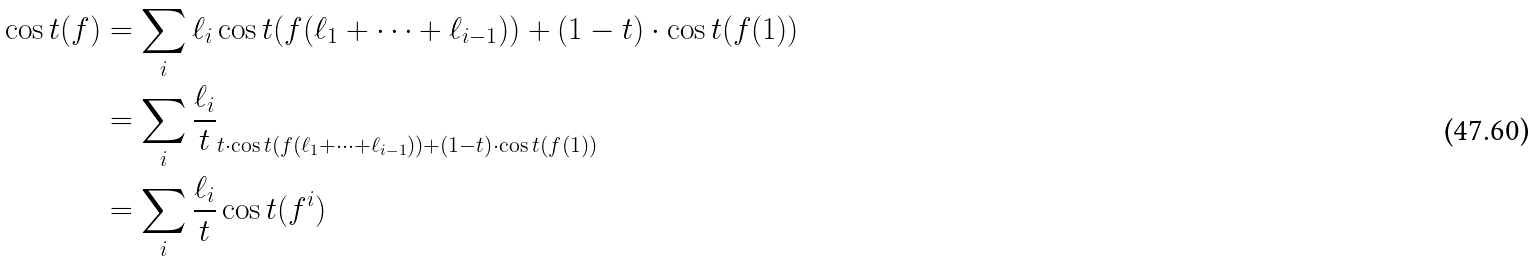Convert formula to latex. <formula><loc_0><loc_0><loc_500><loc_500>\cos t ( f ) & = \sum _ { i } \ell _ { i } \cos t ( f ( \ell _ { 1 } + \dots + \ell _ { i - 1 } ) ) + ( 1 - t ) \cdot \cos t ( f ( 1 ) ) \\ & = \sum _ { i } \frac { \ell _ { i } } { t } _ { t \cdot \cos t ( f ( \ell _ { 1 } + \dots + \ell _ { i - 1 } ) ) + ( 1 - t ) \cdot \cos t ( f ( 1 ) ) } \\ & = \sum _ { i } \frac { \ell _ { i } } { t } \cos t ( f ^ { i } )</formula> 